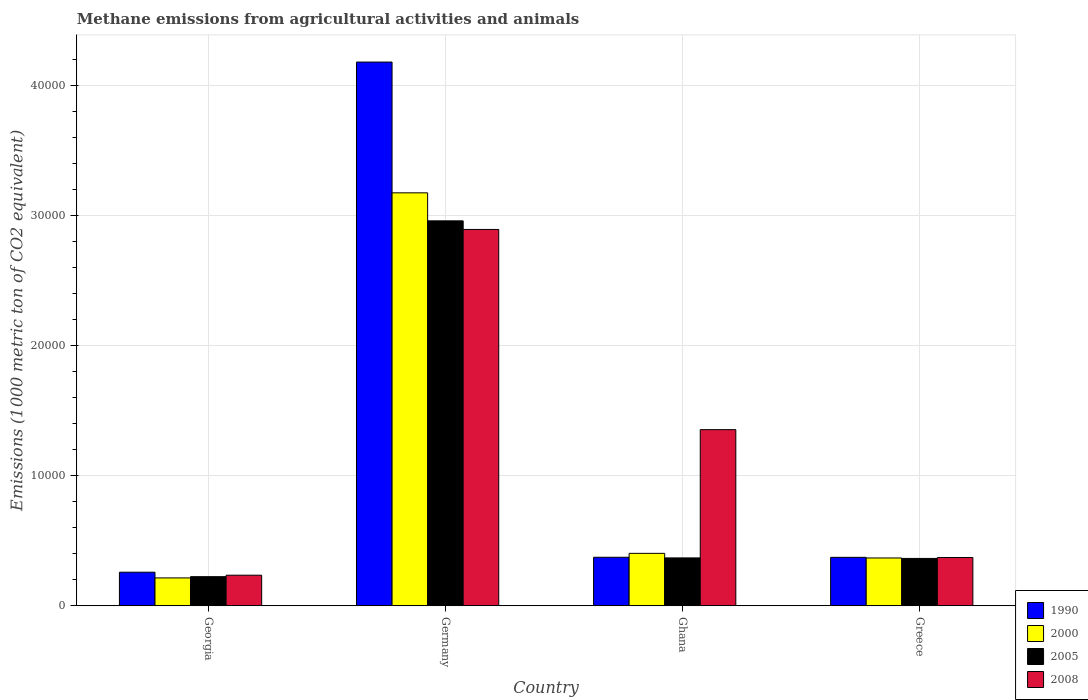How many different coloured bars are there?
Provide a succinct answer. 4. How many groups of bars are there?
Keep it short and to the point. 4. Are the number of bars per tick equal to the number of legend labels?
Give a very brief answer. Yes. Are the number of bars on each tick of the X-axis equal?
Offer a terse response. Yes. What is the label of the 3rd group of bars from the left?
Your answer should be very brief. Ghana. What is the amount of methane emitted in 1990 in Ghana?
Your response must be concise. 3733.1. Across all countries, what is the maximum amount of methane emitted in 1990?
Offer a very short reply. 4.18e+04. Across all countries, what is the minimum amount of methane emitted in 2005?
Offer a very short reply. 2240.7. In which country was the amount of methane emitted in 2005 maximum?
Offer a terse response. Germany. In which country was the amount of methane emitted in 1990 minimum?
Your response must be concise. Georgia. What is the total amount of methane emitted in 2005 in the graph?
Offer a terse response. 3.92e+04. What is the difference between the amount of methane emitted in 2008 in Germany and that in Ghana?
Offer a terse response. 1.54e+04. What is the difference between the amount of methane emitted in 2008 in Germany and the amount of methane emitted in 2000 in Ghana?
Offer a very short reply. 2.49e+04. What is the average amount of methane emitted in 2008 per country?
Provide a short and direct response. 1.21e+04. What is the difference between the amount of methane emitted of/in 2005 and amount of methane emitted of/in 1990 in Greece?
Your answer should be very brief. -83.9. What is the ratio of the amount of methane emitted in 2008 in Georgia to that in Ghana?
Provide a short and direct response. 0.17. Is the amount of methane emitted in 1990 in Georgia less than that in Greece?
Ensure brevity in your answer.  Yes. What is the difference between the highest and the second highest amount of methane emitted in 1990?
Your answer should be very brief. -3.81e+04. What is the difference between the highest and the lowest amount of methane emitted in 2008?
Keep it short and to the point. 2.66e+04. Is the sum of the amount of methane emitted in 1990 in Georgia and Ghana greater than the maximum amount of methane emitted in 2005 across all countries?
Provide a short and direct response. No. What does the 1st bar from the left in Georgia represents?
Keep it short and to the point. 1990. Is it the case that in every country, the sum of the amount of methane emitted in 2008 and amount of methane emitted in 2005 is greater than the amount of methane emitted in 2000?
Your answer should be compact. Yes. How many countries are there in the graph?
Provide a succinct answer. 4. Does the graph contain any zero values?
Your response must be concise. No. Does the graph contain grids?
Provide a short and direct response. Yes. How are the legend labels stacked?
Your answer should be very brief. Vertical. What is the title of the graph?
Offer a very short reply. Methane emissions from agricultural activities and animals. Does "1993" appear as one of the legend labels in the graph?
Offer a very short reply. No. What is the label or title of the X-axis?
Make the answer very short. Country. What is the label or title of the Y-axis?
Offer a terse response. Emissions (1000 metric ton of CO2 equivalent). What is the Emissions (1000 metric ton of CO2 equivalent) of 1990 in Georgia?
Provide a short and direct response. 2583.7. What is the Emissions (1000 metric ton of CO2 equivalent) of 2000 in Georgia?
Give a very brief answer. 2145. What is the Emissions (1000 metric ton of CO2 equivalent) in 2005 in Georgia?
Offer a terse response. 2240.7. What is the Emissions (1000 metric ton of CO2 equivalent) of 2008 in Georgia?
Offer a very short reply. 2354. What is the Emissions (1000 metric ton of CO2 equivalent) in 1990 in Germany?
Offer a very short reply. 4.18e+04. What is the Emissions (1000 metric ton of CO2 equivalent) of 2000 in Germany?
Make the answer very short. 3.18e+04. What is the Emissions (1000 metric ton of CO2 equivalent) of 2005 in Germany?
Your answer should be compact. 2.96e+04. What is the Emissions (1000 metric ton of CO2 equivalent) in 2008 in Germany?
Give a very brief answer. 2.90e+04. What is the Emissions (1000 metric ton of CO2 equivalent) of 1990 in Ghana?
Offer a terse response. 3733.1. What is the Emissions (1000 metric ton of CO2 equivalent) in 2000 in Ghana?
Your answer should be compact. 4034.5. What is the Emissions (1000 metric ton of CO2 equivalent) of 2005 in Ghana?
Offer a very short reply. 3684.4. What is the Emissions (1000 metric ton of CO2 equivalent) of 2008 in Ghana?
Offer a terse response. 1.36e+04. What is the Emissions (1000 metric ton of CO2 equivalent) of 1990 in Greece?
Offer a terse response. 3728.5. What is the Emissions (1000 metric ton of CO2 equivalent) in 2000 in Greece?
Your answer should be compact. 3679.3. What is the Emissions (1000 metric ton of CO2 equivalent) in 2005 in Greece?
Your answer should be very brief. 3644.6. What is the Emissions (1000 metric ton of CO2 equivalent) in 2008 in Greece?
Make the answer very short. 3714.1. Across all countries, what is the maximum Emissions (1000 metric ton of CO2 equivalent) in 1990?
Ensure brevity in your answer.  4.18e+04. Across all countries, what is the maximum Emissions (1000 metric ton of CO2 equivalent) in 2000?
Provide a succinct answer. 3.18e+04. Across all countries, what is the maximum Emissions (1000 metric ton of CO2 equivalent) of 2005?
Make the answer very short. 2.96e+04. Across all countries, what is the maximum Emissions (1000 metric ton of CO2 equivalent) in 2008?
Ensure brevity in your answer.  2.90e+04. Across all countries, what is the minimum Emissions (1000 metric ton of CO2 equivalent) in 1990?
Keep it short and to the point. 2583.7. Across all countries, what is the minimum Emissions (1000 metric ton of CO2 equivalent) in 2000?
Offer a terse response. 2145. Across all countries, what is the minimum Emissions (1000 metric ton of CO2 equivalent) in 2005?
Give a very brief answer. 2240.7. Across all countries, what is the minimum Emissions (1000 metric ton of CO2 equivalent) of 2008?
Keep it short and to the point. 2354. What is the total Emissions (1000 metric ton of CO2 equivalent) in 1990 in the graph?
Provide a short and direct response. 5.19e+04. What is the total Emissions (1000 metric ton of CO2 equivalent) in 2000 in the graph?
Make the answer very short. 4.16e+04. What is the total Emissions (1000 metric ton of CO2 equivalent) of 2005 in the graph?
Offer a very short reply. 3.92e+04. What is the total Emissions (1000 metric ton of CO2 equivalent) of 2008 in the graph?
Offer a terse response. 4.86e+04. What is the difference between the Emissions (1000 metric ton of CO2 equivalent) of 1990 in Georgia and that in Germany?
Give a very brief answer. -3.93e+04. What is the difference between the Emissions (1000 metric ton of CO2 equivalent) of 2000 in Georgia and that in Germany?
Your answer should be compact. -2.96e+04. What is the difference between the Emissions (1000 metric ton of CO2 equivalent) in 2005 in Georgia and that in Germany?
Provide a short and direct response. -2.74e+04. What is the difference between the Emissions (1000 metric ton of CO2 equivalent) of 2008 in Georgia and that in Germany?
Your answer should be very brief. -2.66e+04. What is the difference between the Emissions (1000 metric ton of CO2 equivalent) in 1990 in Georgia and that in Ghana?
Provide a short and direct response. -1149.4. What is the difference between the Emissions (1000 metric ton of CO2 equivalent) in 2000 in Georgia and that in Ghana?
Your answer should be very brief. -1889.5. What is the difference between the Emissions (1000 metric ton of CO2 equivalent) of 2005 in Georgia and that in Ghana?
Your answer should be compact. -1443.7. What is the difference between the Emissions (1000 metric ton of CO2 equivalent) of 2008 in Georgia and that in Ghana?
Keep it short and to the point. -1.12e+04. What is the difference between the Emissions (1000 metric ton of CO2 equivalent) in 1990 in Georgia and that in Greece?
Your answer should be very brief. -1144.8. What is the difference between the Emissions (1000 metric ton of CO2 equivalent) of 2000 in Georgia and that in Greece?
Ensure brevity in your answer.  -1534.3. What is the difference between the Emissions (1000 metric ton of CO2 equivalent) of 2005 in Georgia and that in Greece?
Ensure brevity in your answer.  -1403.9. What is the difference between the Emissions (1000 metric ton of CO2 equivalent) in 2008 in Georgia and that in Greece?
Your answer should be compact. -1360.1. What is the difference between the Emissions (1000 metric ton of CO2 equivalent) of 1990 in Germany and that in Ghana?
Ensure brevity in your answer.  3.81e+04. What is the difference between the Emissions (1000 metric ton of CO2 equivalent) of 2000 in Germany and that in Ghana?
Ensure brevity in your answer.  2.77e+04. What is the difference between the Emissions (1000 metric ton of CO2 equivalent) of 2005 in Germany and that in Ghana?
Your answer should be compact. 2.59e+04. What is the difference between the Emissions (1000 metric ton of CO2 equivalent) of 2008 in Germany and that in Ghana?
Ensure brevity in your answer.  1.54e+04. What is the difference between the Emissions (1000 metric ton of CO2 equivalent) in 1990 in Germany and that in Greece?
Give a very brief answer. 3.81e+04. What is the difference between the Emissions (1000 metric ton of CO2 equivalent) of 2000 in Germany and that in Greece?
Offer a terse response. 2.81e+04. What is the difference between the Emissions (1000 metric ton of CO2 equivalent) in 2005 in Germany and that in Greece?
Offer a very short reply. 2.60e+04. What is the difference between the Emissions (1000 metric ton of CO2 equivalent) of 2008 in Germany and that in Greece?
Your answer should be compact. 2.52e+04. What is the difference between the Emissions (1000 metric ton of CO2 equivalent) in 1990 in Ghana and that in Greece?
Ensure brevity in your answer.  4.6. What is the difference between the Emissions (1000 metric ton of CO2 equivalent) in 2000 in Ghana and that in Greece?
Offer a very short reply. 355.2. What is the difference between the Emissions (1000 metric ton of CO2 equivalent) of 2005 in Ghana and that in Greece?
Offer a terse response. 39.8. What is the difference between the Emissions (1000 metric ton of CO2 equivalent) of 2008 in Ghana and that in Greece?
Offer a terse response. 9838.3. What is the difference between the Emissions (1000 metric ton of CO2 equivalent) of 1990 in Georgia and the Emissions (1000 metric ton of CO2 equivalent) of 2000 in Germany?
Keep it short and to the point. -2.92e+04. What is the difference between the Emissions (1000 metric ton of CO2 equivalent) of 1990 in Georgia and the Emissions (1000 metric ton of CO2 equivalent) of 2005 in Germany?
Provide a short and direct response. -2.70e+04. What is the difference between the Emissions (1000 metric ton of CO2 equivalent) of 1990 in Georgia and the Emissions (1000 metric ton of CO2 equivalent) of 2008 in Germany?
Offer a very short reply. -2.64e+04. What is the difference between the Emissions (1000 metric ton of CO2 equivalent) in 2000 in Georgia and the Emissions (1000 metric ton of CO2 equivalent) in 2005 in Germany?
Give a very brief answer. -2.75e+04. What is the difference between the Emissions (1000 metric ton of CO2 equivalent) of 2000 in Georgia and the Emissions (1000 metric ton of CO2 equivalent) of 2008 in Germany?
Provide a succinct answer. -2.68e+04. What is the difference between the Emissions (1000 metric ton of CO2 equivalent) of 2005 in Georgia and the Emissions (1000 metric ton of CO2 equivalent) of 2008 in Germany?
Your response must be concise. -2.67e+04. What is the difference between the Emissions (1000 metric ton of CO2 equivalent) in 1990 in Georgia and the Emissions (1000 metric ton of CO2 equivalent) in 2000 in Ghana?
Give a very brief answer. -1450.8. What is the difference between the Emissions (1000 metric ton of CO2 equivalent) of 1990 in Georgia and the Emissions (1000 metric ton of CO2 equivalent) of 2005 in Ghana?
Ensure brevity in your answer.  -1100.7. What is the difference between the Emissions (1000 metric ton of CO2 equivalent) of 1990 in Georgia and the Emissions (1000 metric ton of CO2 equivalent) of 2008 in Ghana?
Offer a very short reply. -1.10e+04. What is the difference between the Emissions (1000 metric ton of CO2 equivalent) in 2000 in Georgia and the Emissions (1000 metric ton of CO2 equivalent) in 2005 in Ghana?
Your answer should be compact. -1539.4. What is the difference between the Emissions (1000 metric ton of CO2 equivalent) of 2000 in Georgia and the Emissions (1000 metric ton of CO2 equivalent) of 2008 in Ghana?
Your answer should be compact. -1.14e+04. What is the difference between the Emissions (1000 metric ton of CO2 equivalent) in 2005 in Georgia and the Emissions (1000 metric ton of CO2 equivalent) in 2008 in Ghana?
Ensure brevity in your answer.  -1.13e+04. What is the difference between the Emissions (1000 metric ton of CO2 equivalent) in 1990 in Georgia and the Emissions (1000 metric ton of CO2 equivalent) in 2000 in Greece?
Ensure brevity in your answer.  -1095.6. What is the difference between the Emissions (1000 metric ton of CO2 equivalent) of 1990 in Georgia and the Emissions (1000 metric ton of CO2 equivalent) of 2005 in Greece?
Your answer should be very brief. -1060.9. What is the difference between the Emissions (1000 metric ton of CO2 equivalent) of 1990 in Georgia and the Emissions (1000 metric ton of CO2 equivalent) of 2008 in Greece?
Offer a very short reply. -1130.4. What is the difference between the Emissions (1000 metric ton of CO2 equivalent) in 2000 in Georgia and the Emissions (1000 metric ton of CO2 equivalent) in 2005 in Greece?
Provide a short and direct response. -1499.6. What is the difference between the Emissions (1000 metric ton of CO2 equivalent) of 2000 in Georgia and the Emissions (1000 metric ton of CO2 equivalent) of 2008 in Greece?
Provide a succinct answer. -1569.1. What is the difference between the Emissions (1000 metric ton of CO2 equivalent) of 2005 in Georgia and the Emissions (1000 metric ton of CO2 equivalent) of 2008 in Greece?
Keep it short and to the point. -1473.4. What is the difference between the Emissions (1000 metric ton of CO2 equivalent) of 1990 in Germany and the Emissions (1000 metric ton of CO2 equivalent) of 2000 in Ghana?
Make the answer very short. 3.78e+04. What is the difference between the Emissions (1000 metric ton of CO2 equivalent) of 1990 in Germany and the Emissions (1000 metric ton of CO2 equivalent) of 2005 in Ghana?
Make the answer very short. 3.82e+04. What is the difference between the Emissions (1000 metric ton of CO2 equivalent) of 1990 in Germany and the Emissions (1000 metric ton of CO2 equivalent) of 2008 in Ghana?
Keep it short and to the point. 2.83e+04. What is the difference between the Emissions (1000 metric ton of CO2 equivalent) in 2000 in Germany and the Emissions (1000 metric ton of CO2 equivalent) in 2005 in Ghana?
Make the answer very short. 2.81e+04. What is the difference between the Emissions (1000 metric ton of CO2 equivalent) of 2000 in Germany and the Emissions (1000 metric ton of CO2 equivalent) of 2008 in Ghana?
Provide a succinct answer. 1.82e+04. What is the difference between the Emissions (1000 metric ton of CO2 equivalent) in 2005 in Germany and the Emissions (1000 metric ton of CO2 equivalent) in 2008 in Ghana?
Make the answer very short. 1.61e+04. What is the difference between the Emissions (1000 metric ton of CO2 equivalent) in 1990 in Germany and the Emissions (1000 metric ton of CO2 equivalent) in 2000 in Greece?
Give a very brief answer. 3.82e+04. What is the difference between the Emissions (1000 metric ton of CO2 equivalent) in 1990 in Germany and the Emissions (1000 metric ton of CO2 equivalent) in 2005 in Greece?
Your answer should be compact. 3.82e+04. What is the difference between the Emissions (1000 metric ton of CO2 equivalent) of 1990 in Germany and the Emissions (1000 metric ton of CO2 equivalent) of 2008 in Greece?
Offer a terse response. 3.81e+04. What is the difference between the Emissions (1000 metric ton of CO2 equivalent) of 2000 in Germany and the Emissions (1000 metric ton of CO2 equivalent) of 2005 in Greece?
Your response must be concise. 2.81e+04. What is the difference between the Emissions (1000 metric ton of CO2 equivalent) in 2000 in Germany and the Emissions (1000 metric ton of CO2 equivalent) in 2008 in Greece?
Make the answer very short. 2.81e+04. What is the difference between the Emissions (1000 metric ton of CO2 equivalent) in 2005 in Germany and the Emissions (1000 metric ton of CO2 equivalent) in 2008 in Greece?
Offer a terse response. 2.59e+04. What is the difference between the Emissions (1000 metric ton of CO2 equivalent) in 1990 in Ghana and the Emissions (1000 metric ton of CO2 equivalent) in 2000 in Greece?
Provide a succinct answer. 53.8. What is the difference between the Emissions (1000 metric ton of CO2 equivalent) of 1990 in Ghana and the Emissions (1000 metric ton of CO2 equivalent) of 2005 in Greece?
Give a very brief answer. 88.5. What is the difference between the Emissions (1000 metric ton of CO2 equivalent) in 1990 in Ghana and the Emissions (1000 metric ton of CO2 equivalent) in 2008 in Greece?
Keep it short and to the point. 19. What is the difference between the Emissions (1000 metric ton of CO2 equivalent) of 2000 in Ghana and the Emissions (1000 metric ton of CO2 equivalent) of 2005 in Greece?
Your answer should be compact. 389.9. What is the difference between the Emissions (1000 metric ton of CO2 equivalent) of 2000 in Ghana and the Emissions (1000 metric ton of CO2 equivalent) of 2008 in Greece?
Keep it short and to the point. 320.4. What is the difference between the Emissions (1000 metric ton of CO2 equivalent) in 2005 in Ghana and the Emissions (1000 metric ton of CO2 equivalent) in 2008 in Greece?
Provide a succinct answer. -29.7. What is the average Emissions (1000 metric ton of CO2 equivalent) in 1990 per country?
Make the answer very short. 1.30e+04. What is the average Emissions (1000 metric ton of CO2 equivalent) of 2000 per country?
Offer a very short reply. 1.04e+04. What is the average Emissions (1000 metric ton of CO2 equivalent) in 2005 per country?
Ensure brevity in your answer.  9796.98. What is the average Emissions (1000 metric ton of CO2 equivalent) of 2008 per country?
Offer a very short reply. 1.21e+04. What is the difference between the Emissions (1000 metric ton of CO2 equivalent) of 1990 and Emissions (1000 metric ton of CO2 equivalent) of 2000 in Georgia?
Your answer should be compact. 438.7. What is the difference between the Emissions (1000 metric ton of CO2 equivalent) of 1990 and Emissions (1000 metric ton of CO2 equivalent) of 2005 in Georgia?
Provide a short and direct response. 343. What is the difference between the Emissions (1000 metric ton of CO2 equivalent) of 1990 and Emissions (1000 metric ton of CO2 equivalent) of 2008 in Georgia?
Make the answer very short. 229.7. What is the difference between the Emissions (1000 metric ton of CO2 equivalent) of 2000 and Emissions (1000 metric ton of CO2 equivalent) of 2005 in Georgia?
Make the answer very short. -95.7. What is the difference between the Emissions (1000 metric ton of CO2 equivalent) in 2000 and Emissions (1000 metric ton of CO2 equivalent) in 2008 in Georgia?
Your answer should be compact. -209. What is the difference between the Emissions (1000 metric ton of CO2 equivalent) in 2005 and Emissions (1000 metric ton of CO2 equivalent) in 2008 in Georgia?
Make the answer very short. -113.3. What is the difference between the Emissions (1000 metric ton of CO2 equivalent) of 1990 and Emissions (1000 metric ton of CO2 equivalent) of 2000 in Germany?
Make the answer very short. 1.01e+04. What is the difference between the Emissions (1000 metric ton of CO2 equivalent) in 1990 and Emissions (1000 metric ton of CO2 equivalent) in 2005 in Germany?
Offer a very short reply. 1.22e+04. What is the difference between the Emissions (1000 metric ton of CO2 equivalent) in 1990 and Emissions (1000 metric ton of CO2 equivalent) in 2008 in Germany?
Your response must be concise. 1.29e+04. What is the difference between the Emissions (1000 metric ton of CO2 equivalent) in 2000 and Emissions (1000 metric ton of CO2 equivalent) in 2005 in Germany?
Ensure brevity in your answer.  2155.4. What is the difference between the Emissions (1000 metric ton of CO2 equivalent) of 2000 and Emissions (1000 metric ton of CO2 equivalent) of 2008 in Germany?
Provide a short and direct response. 2816.4. What is the difference between the Emissions (1000 metric ton of CO2 equivalent) in 2005 and Emissions (1000 metric ton of CO2 equivalent) in 2008 in Germany?
Offer a terse response. 661. What is the difference between the Emissions (1000 metric ton of CO2 equivalent) of 1990 and Emissions (1000 metric ton of CO2 equivalent) of 2000 in Ghana?
Offer a very short reply. -301.4. What is the difference between the Emissions (1000 metric ton of CO2 equivalent) of 1990 and Emissions (1000 metric ton of CO2 equivalent) of 2005 in Ghana?
Give a very brief answer. 48.7. What is the difference between the Emissions (1000 metric ton of CO2 equivalent) in 1990 and Emissions (1000 metric ton of CO2 equivalent) in 2008 in Ghana?
Provide a succinct answer. -9819.3. What is the difference between the Emissions (1000 metric ton of CO2 equivalent) in 2000 and Emissions (1000 metric ton of CO2 equivalent) in 2005 in Ghana?
Offer a very short reply. 350.1. What is the difference between the Emissions (1000 metric ton of CO2 equivalent) of 2000 and Emissions (1000 metric ton of CO2 equivalent) of 2008 in Ghana?
Your response must be concise. -9517.9. What is the difference between the Emissions (1000 metric ton of CO2 equivalent) of 2005 and Emissions (1000 metric ton of CO2 equivalent) of 2008 in Ghana?
Offer a terse response. -9868. What is the difference between the Emissions (1000 metric ton of CO2 equivalent) in 1990 and Emissions (1000 metric ton of CO2 equivalent) in 2000 in Greece?
Your response must be concise. 49.2. What is the difference between the Emissions (1000 metric ton of CO2 equivalent) in 1990 and Emissions (1000 metric ton of CO2 equivalent) in 2005 in Greece?
Your answer should be very brief. 83.9. What is the difference between the Emissions (1000 metric ton of CO2 equivalent) of 1990 and Emissions (1000 metric ton of CO2 equivalent) of 2008 in Greece?
Your answer should be very brief. 14.4. What is the difference between the Emissions (1000 metric ton of CO2 equivalent) of 2000 and Emissions (1000 metric ton of CO2 equivalent) of 2005 in Greece?
Your answer should be very brief. 34.7. What is the difference between the Emissions (1000 metric ton of CO2 equivalent) in 2000 and Emissions (1000 metric ton of CO2 equivalent) in 2008 in Greece?
Ensure brevity in your answer.  -34.8. What is the difference between the Emissions (1000 metric ton of CO2 equivalent) of 2005 and Emissions (1000 metric ton of CO2 equivalent) of 2008 in Greece?
Provide a short and direct response. -69.5. What is the ratio of the Emissions (1000 metric ton of CO2 equivalent) of 1990 in Georgia to that in Germany?
Provide a short and direct response. 0.06. What is the ratio of the Emissions (1000 metric ton of CO2 equivalent) in 2000 in Georgia to that in Germany?
Make the answer very short. 0.07. What is the ratio of the Emissions (1000 metric ton of CO2 equivalent) in 2005 in Georgia to that in Germany?
Provide a short and direct response. 0.08. What is the ratio of the Emissions (1000 metric ton of CO2 equivalent) in 2008 in Georgia to that in Germany?
Offer a very short reply. 0.08. What is the ratio of the Emissions (1000 metric ton of CO2 equivalent) in 1990 in Georgia to that in Ghana?
Keep it short and to the point. 0.69. What is the ratio of the Emissions (1000 metric ton of CO2 equivalent) of 2000 in Georgia to that in Ghana?
Offer a very short reply. 0.53. What is the ratio of the Emissions (1000 metric ton of CO2 equivalent) in 2005 in Georgia to that in Ghana?
Keep it short and to the point. 0.61. What is the ratio of the Emissions (1000 metric ton of CO2 equivalent) in 2008 in Georgia to that in Ghana?
Keep it short and to the point. 0.17. What is the ratio of the Emissions (1000 metric ton of CO2 equivalent) in 1990 in Georgia to that in Greece?
Provide a succinct answer. 0.69. What is the ratio of the Emissions (1000 metric ton of CO2 equivalent) of 2000 in Georgia to that in Greece?
Give a very brief answer. 0.58. What is the ratio of the Emissions (1000 metric ton of CO2 equivalent) in 2005 in Georgia to that in Greece?
Offer a very short reply. 0.61. What is the ratio of the Emissions (1000 metric ton of CO2 equivalent) in 2008 in Georgia to that in Greece?
Provide a short and direct response. 0.63. What is the ratio of the Emissions (1000 metric ton of CO2 equivalent) of 1990 in Germany to that in Ghana?
Offer a very short reply. 11.21. What is the ratio of the Emissions (1000 metric ton of CO2 equivalent) of 2000 in Germany to that in Ghana?
Offer a very short reply. 7.88. What is the ratio of the Emissions (1000 metric ton of CO2 equivalent) in 2005 in Germany to that in Ghana?
Give a very brief answer. 8.04. What is the ratio of the Emissions (1000 metric ton of CO2 equivalent) in 2008 in Germany to that in Ghana?
Provide a succinct answer. 2.14. What is the ratio of the Emissions (1000 metric ton of CO2 equivalent) in 1990 in Germany to that in Greece?
Your answer should be compact. 11.22. What is the ratio of the Emissions (1000 metric ton of CO2 equivalent) of 2000 in Germany to that in Greece?
Provide a succinct answer. 8.64. What is the ratio of the Emissions (1000 metric ton of CO2 equivalent) in 2005 in Germany to that in Greece?
Provide a succinct answer. 8.13. What is the ratio of the Emissions (1000 metric ton of CO2 equivalent) in 2008 in Germany to that in Greece?
Provide a succinct answer. 7.8. What is the ratio of the Emissions (1000 metric ton of CO2 equivalent) of 2000 in Ghana to that in Greece?
Offer a terse response. 1.1. What is the ratio of the Emissions (1000 metric ton of CO2 equivalent) in 2005 in Ghana to that in Greece?
Give a very brief answer. 1.01. What is the ratio of the Emissions (1000 metric ton of CO2 equivalent) in 2008 in Ghana to that in Greece?
Your answer should be very brief. 3.65. What is the difference between the highest and the second highest Emissions (1000 metric ton of CO2 equivalent) in 1990?
Keep it short and to the point. 3.81e+04. What is the difference between the highest and the second highest Emissions (1000 metric ton of CO2 equivalent) in 2000?
Your answer should be very brief. 2.77e+04. What is the difference between the highest and the second highest Emissions (1000 metric ton of CO2 equivalent) of 2005?
Make the answer very short. 2.59e+04. What is the difference between the highest and the second highest Emissions (1000 metric ton of CO2 equivalent) in 2008?
Provide a succinct answer. 1.54e+04. What is the difference between the highest and the lowest Emissions (1000 metric ton of CO2 equivalent) of 1990?
Make the answer very short. 3.93e+04. What is the difference between the highest and the lowest Emissions (1000 metric ton of CO2 equivalent) in 2000?
Keep it short and to the point. 2.96e+04. What is the difference between the highest and the lowest Emissions (1000 metric ton of CO2 equivalent) in 2005?
Provide a short and direct response. 2.74e+04. What is the difference between the highest and the lowest Emissions (1000 metric ton of CO2 equivalent) of 2008?
Provide a short and direct response. 2.66e+04. 